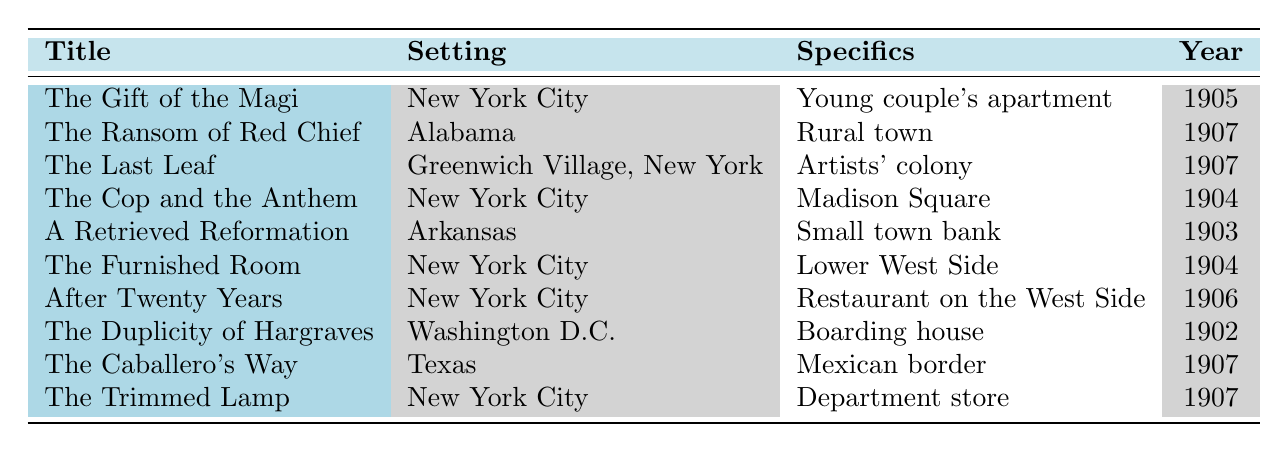What is the setting of "The Gift of the Magi"? In the table, under the title "The Gift of the Magi," the setting is listed as "New York City."
Answer: New York City How many stories are set in New York City? By examining the table, we see that there are five stories with the setting "New York City." They are "The Gift of the Magi," "The Cop and the Anthem," "The Furnished Room," "After Twenty Years," and "The Trimmed Lamp."
Answer: 5 What year was "A Retrieved Reformation" published? The table specifies that "A Retrieved Reformation" was published in the year 1903.
Answer: 1903 In which story is the setting a rural town? The only story identified with the setting "Rural town" is "The Ransom of Red Chief."
Answer: The Ransom of Red Chief Which story takes place in a boarding house? From the table, "The Duplicity of Hargraves" is the story set in a boarding house, as indicated in the specifics column.
Answer: The Duplicity of Hargraves What is the difference in publication years between "The Last Leaf" and "The Caballero's Way"? "The Last Leaf" was published in 1907 and "The Caballero's Way" was published in 1907. The difference is 1907 - 1907 = 0.
Answer: 0 Is "Arkansas" a setting for any story in this table? Yes, "Arkansas" is listed as the setting for "A Retrieved Reformation."
Answer: Yes Which story set in New York City was published first? Among the stories set in New York City, "The Cop and the Anthem" was the earliest, published in 1904, making it the first listed under that setting.
Answer: The Cop and the Anthem How many stories were published in 1907? Looking at the year column, three stories were published in 1907: "The Ransom of Red Chief," "The Last Leaf," and "The Caballero's Way." Summing these gives 3.
Answer: 3 Which specific setting has the year 1906 associated with it? The story "After Twenty Years," which takes place in a restaurant on the West Side of New York City, is the one specifically associated with the year 1906.
Answer: After Twenty Years 